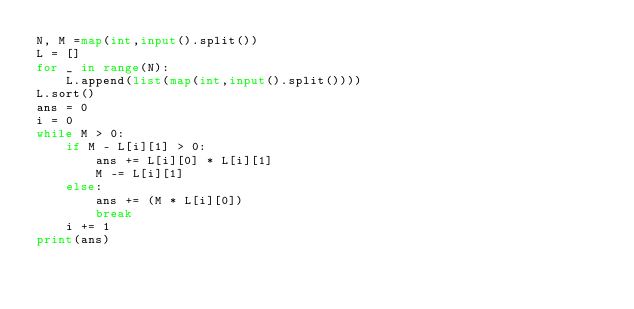Convert code to text. <code><loc_0><loc_0><loc_500><loc_500><_Python_>N, M =map(int,input().split())
L = []
for _ in range(N):
    L.append(list(map(int,input().split())))
L.sort()
ans = 0
i = 0
while M > 0:
    if M - L[i][1] > 0:
        ans += L[i][0] * L[i][1]
        M -= L[i][1]
    else:
        ans += (M * L[i][0])
        break
    i += 1
print(ans)</code> 